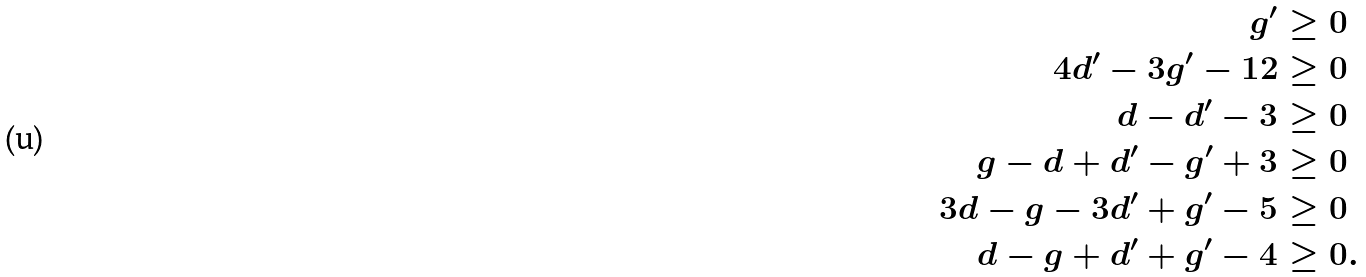Convert formula to latex. <formula><loc_0><loc_0><loc_500><loc_500>g ^ { \prime } & \geq 0 \\ 4 d ^ { \prime } - 3 g ^ { \prime } - 1 2 & \geq 0 \\ d - d ^ { \prime } - 3 & \geq 0 \\ g - d + d ^ { \prime } - g ^ { \prime } + 3 & \geq 0 \\ 3 d - g - 3 d ^ { \prime } + g ^ { \prime } - 5 & \geq 0 \\ d - g + d ^ { \prime } + g ^ { \prime } - 4 & \geq 0 .</formula> 